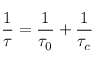<formula> <loc_0><loc_0><loc_500><loc_500>\frac { 1 } { \tau } = \frac { 1 } { \tau _ { 0 } } + \frac { 1 } { \tau _ { c } }</formula> 